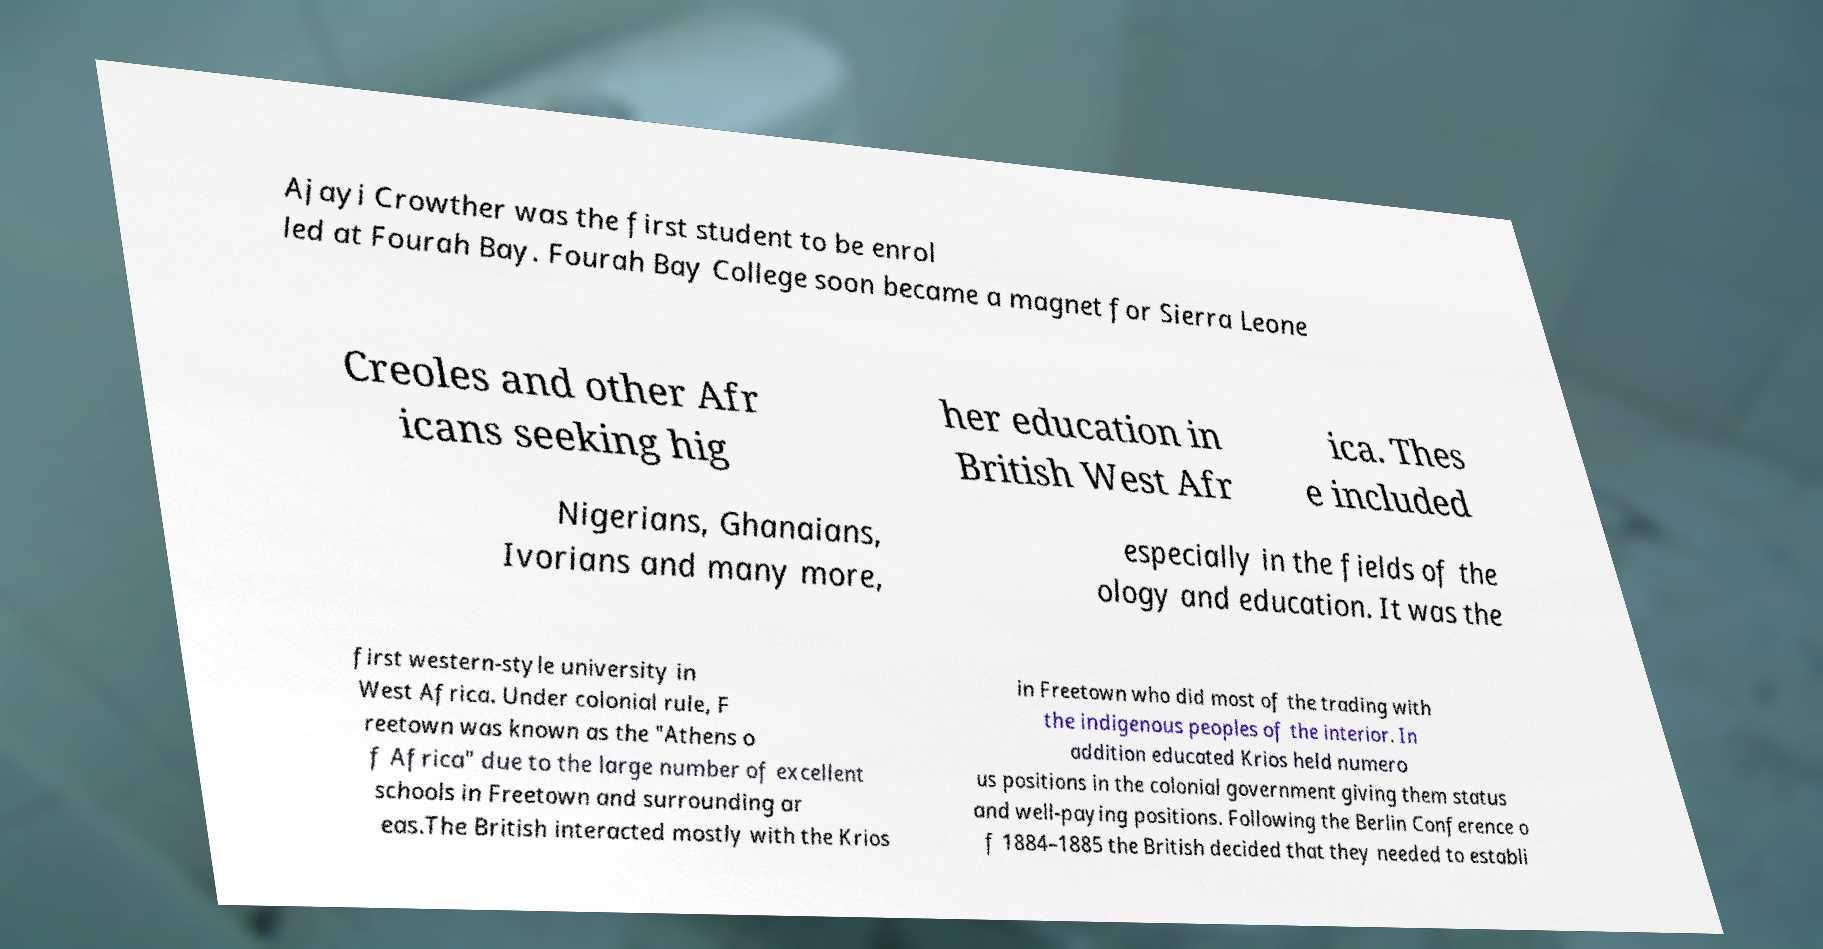Please read and relay the text visible in this image. What does it say? Ajayi Crowther was the first student to be enrol led at Fourah Bay. Fourah Bay College soon became a magnet for Sierra Leone Creoles and other Afr icans seeking hig her education in British West Afr ica. Thes e included Nigerians, Ghanaians, Ivorians and many more, especially in the fields of the ology and education. It was the first western-style university in West Africa. Under colonial rule, F reetown was known as the "Athens o f Africa" due to the large number of excellent schools in Freetown and surrounding ar eas.The British interacted mostly with the Krios in Freetown who did most of the trading with the indigenous peoples of the interior. In addition educated Krios held numero us positions in the colonial government giving them status and well-paying positions. Following the Berlin Conference o f 1884–1885 the British decided that they needed to establi 